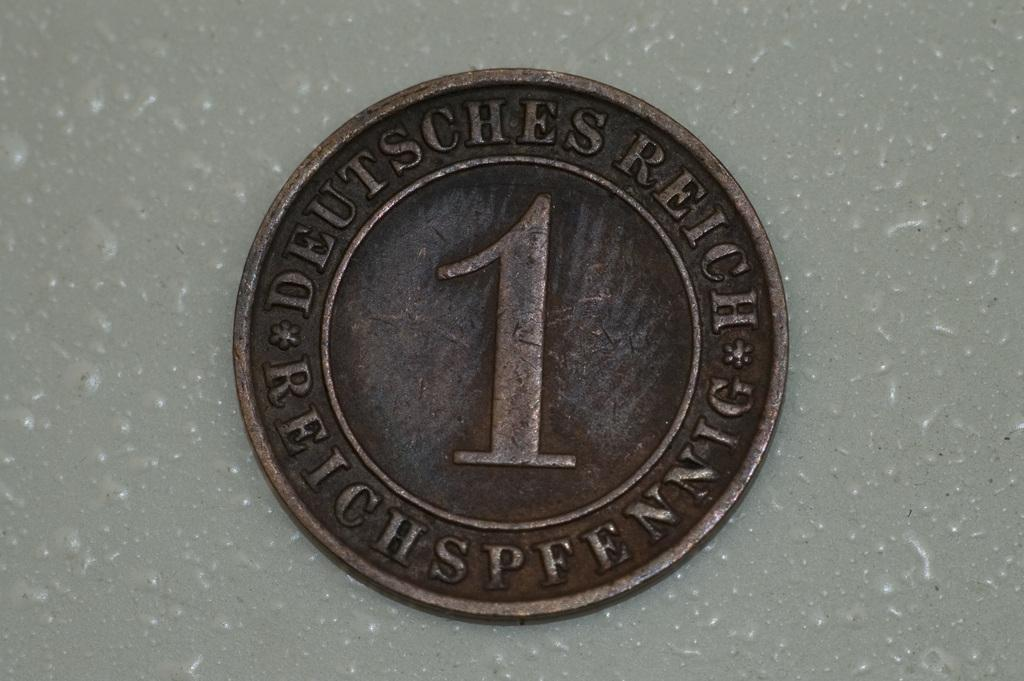<image>
Summarize the visual content of the image. An old german coin with the number 1 in the middle. 